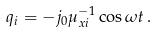<formula> <loc_0><loc_0><loc_500><loc_500>q _ { i } = - j _ { 0 } \mu _ { x i } ^ { - 1 } \cos \omega t \, .</formula> 